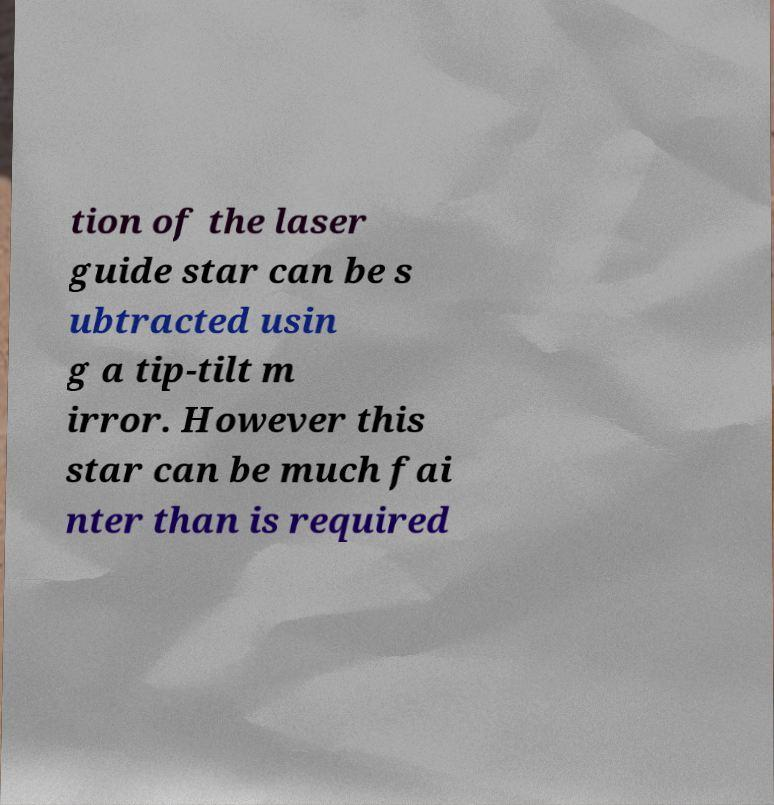There's text embedded in this image that I need extracted. Can you transcribe it verbatim? tion of the laser guide star can be s ubtracted usin g a tip-tilt m irror. However this star can be much fai nter than is required 